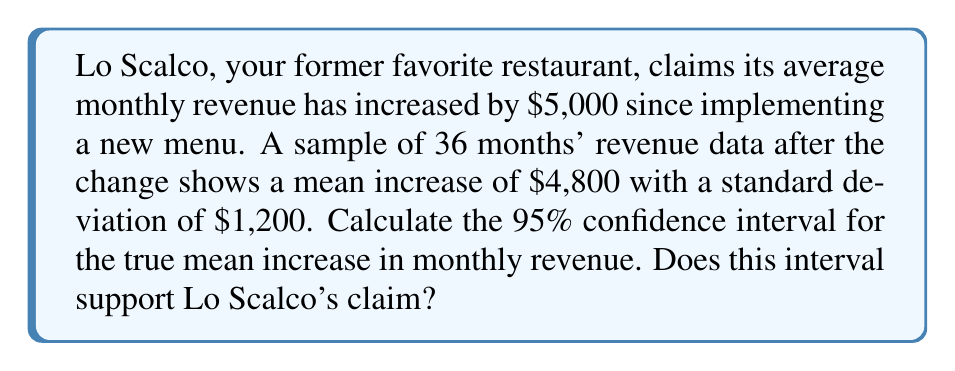Give your solution to this math problem. Let's approach this step-by-step:

1) We're dealing with a confidence interval for a population mean. The formula is:

   $$\bar{x} \pm t_{\alpha/2} \cdot \frac{s}{\sqrt{n}}$$

   where $\bar{x}$ is the sample mean, $s$ is the sample standard deviation, $n$ is the sample size, and $t_{\alpha/2}$ is the t-value for a 95% confidence interval.

2) We know:
   - $\bar{x} = 4800$
   - $s = 1200$
   - $n = 36$
   - For a 95% CI with 35 degrees of freedom (n-1), $t_{\alpha/2} \approx 2.030$ (from t-table)

3) Let's plug these values into our formula:

   $$4800 \pm 2.030 \cdot \frac{1200}{\sqrt{36}}$$

4) Simplify:
   $$4800 \pm 2.030 \cdot \frac{1200}{6} = 4800 \pm 2.030 \cdot 200 = 4800 \pm 406$$

5) Therefore, the 95% confidence interval is:

   $$[4800 - 406, 4800 + 406] = [4394, 5206]$$

6) Interpretation: We are 95% confident that the true mean increase in monthly revenue falls between $4,394 and $5,206.

7) Lo Scalco's claim of a $5,000 increase falls within this interval, so the data supports their claim.
Answer: 95% CI: [$4,394, $5,206]; supports Lo Scalco's claim 